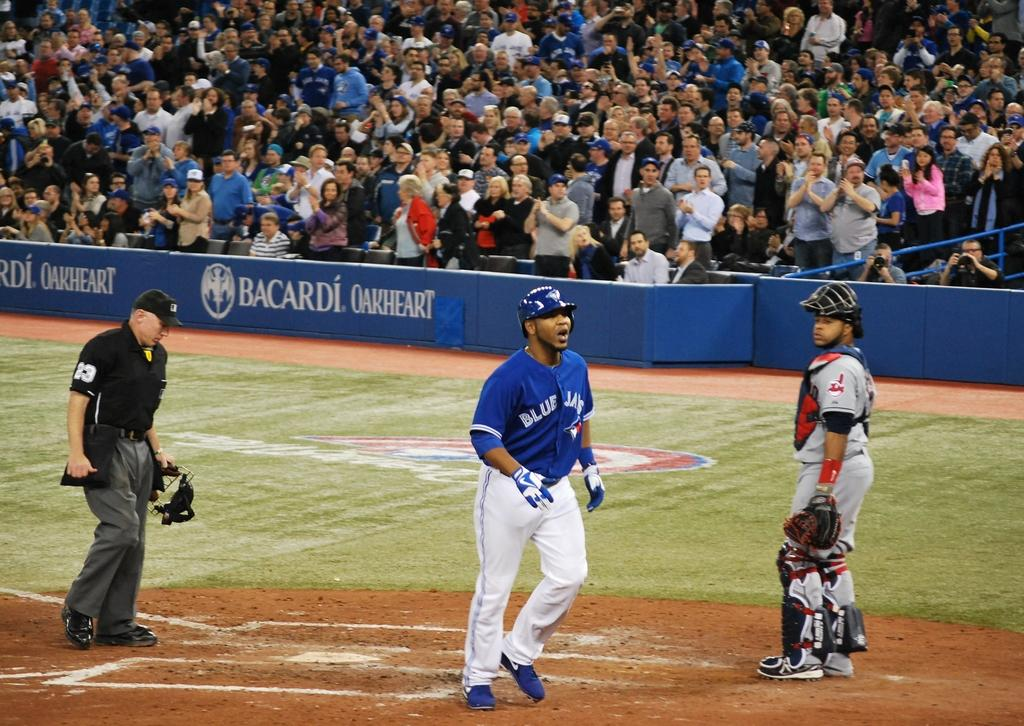<image>
Create a compact narrative representing the image presented. A man in a Blue Jays uniform is on a baseball field. 